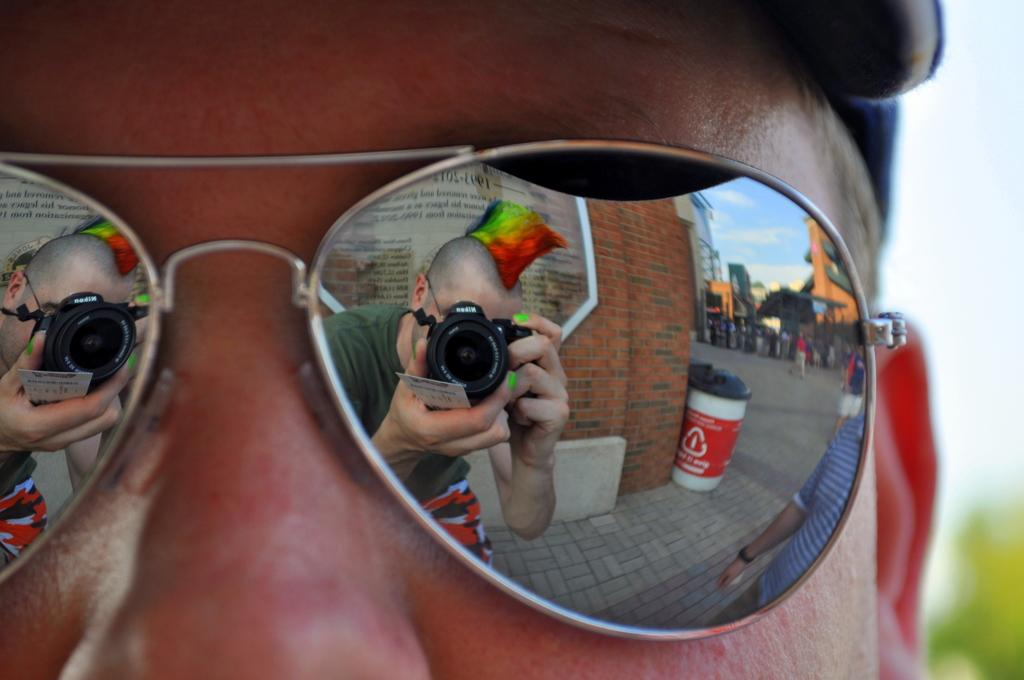What is the main subject of the image? There is a person in the image. What is the person wearing in the image? The person is wearing goggles. Can you describe the reflection in the goggles? There is a reflection of another person in the goggles. What type of lettuce can be seen in the goggles? There is no lettuce present in the image, and therefore it cannot be seen in the goggles. 